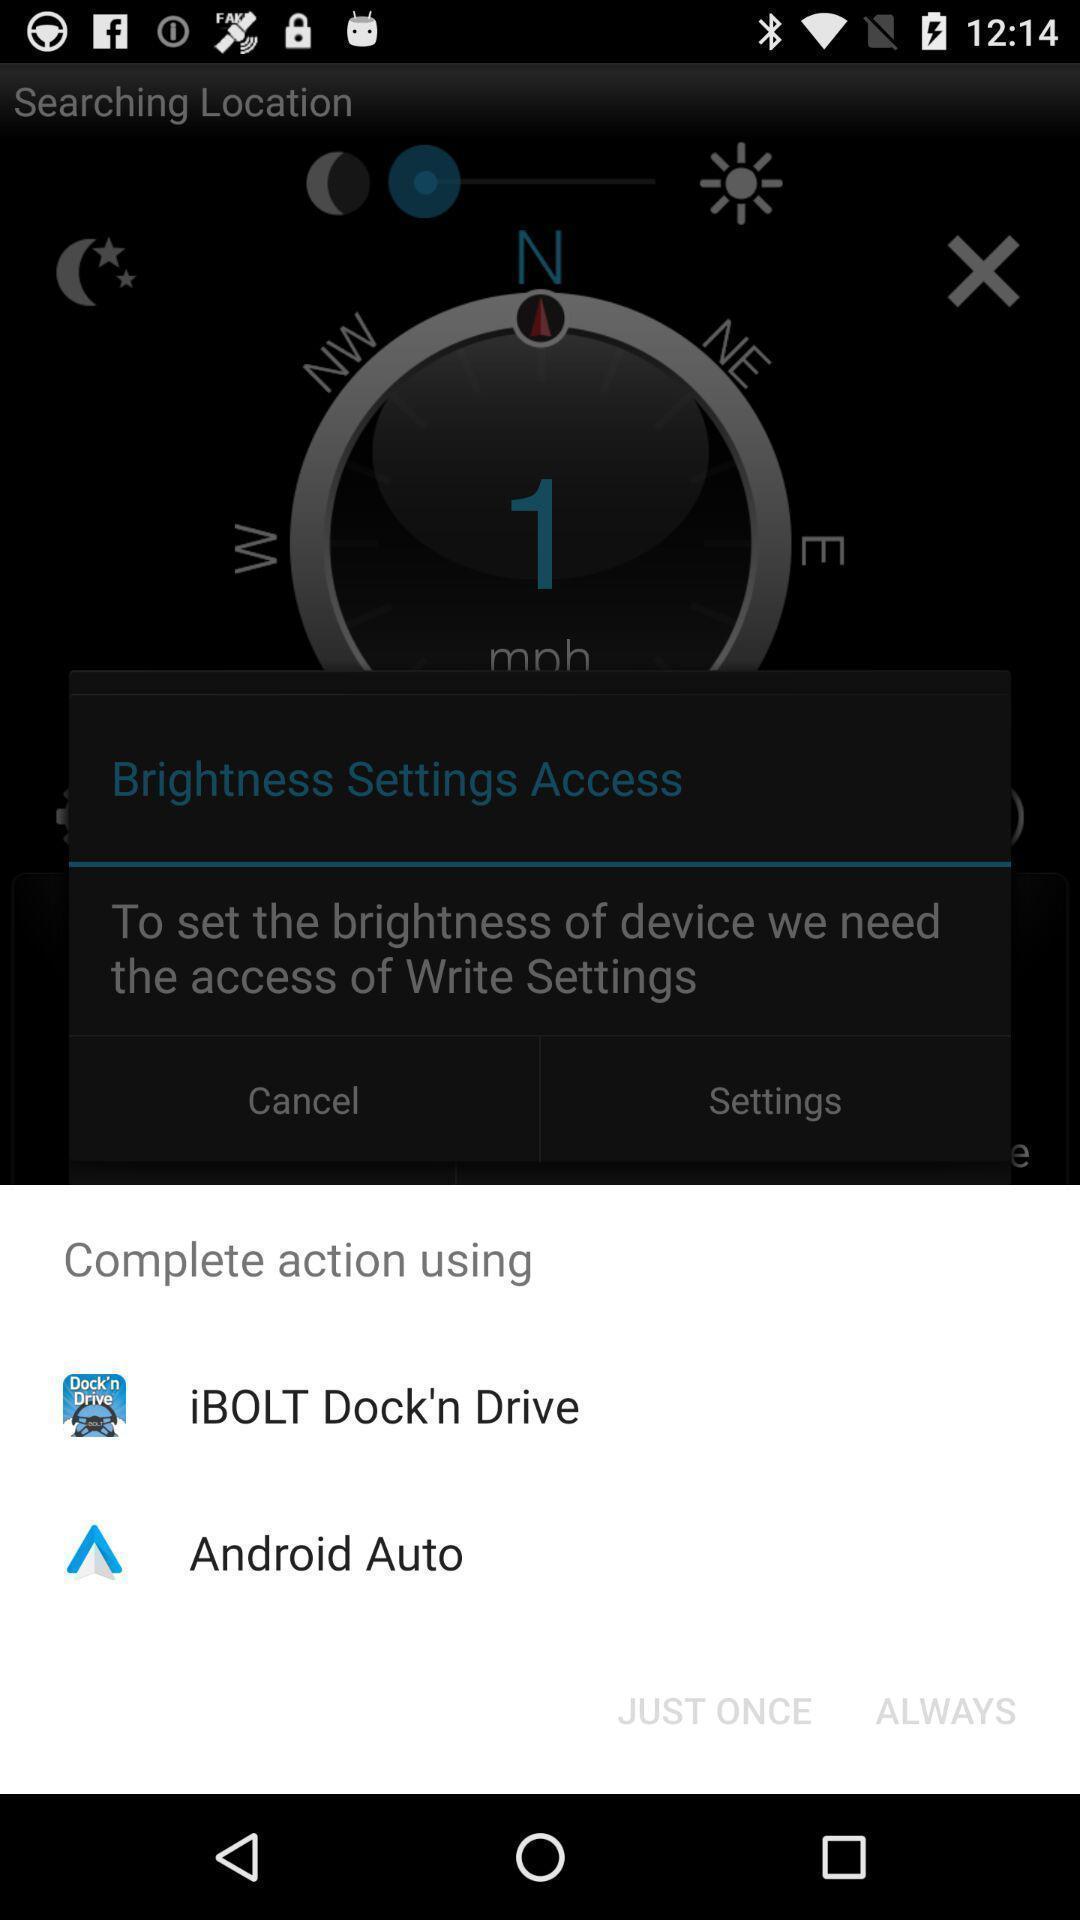Tell me about the visual elements in this screen capture. Popup to use a option in the app. 